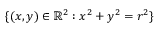<formula> <loc_0><loc_0><loc_500><loc_500>\{ ( x , y ) \in \mathbb { R } ^ { 2 } \colon x ^ { 2 } + y ^ { 2 } = r ^ { 2 } \}</formula> 